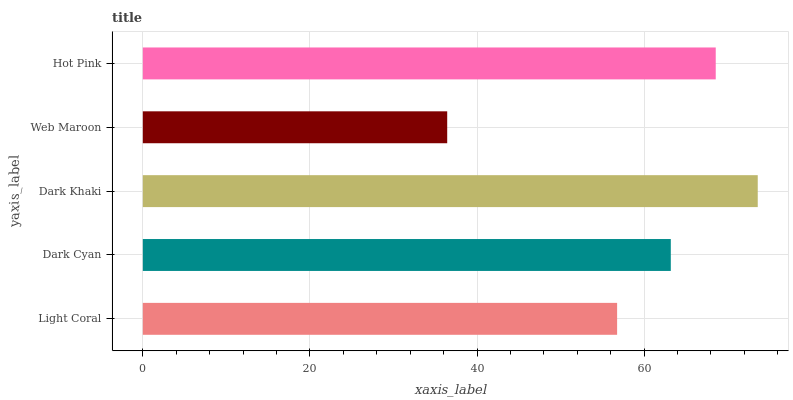Is Web Maroon the minimum?
Answer yes or no. Yes. Is Dark Khaki the maximum?
Answer yes or no. Yes. Is Dark Cyan the minimum?
Answer yes or no. No. Is Dark Cyan the maximum?
Answer yes or no. No. Is Dark Cyan greater than Light Coral?
Answer yes or no. Yes. Is Light Coral less than Dark Cyan?
Answer yes or no. Yes. Is Light Coral greater than Dark Cyan?
Answer yes or no. No. Is Dark Cyan less than Light Coral?
Answer yes or no. No. Is Dark Cyan the high median?
Answer yes or no. Yes. Is Dark Cyan the low median?
Answer yes or no. Yes. Is Web Maroon the high median?
Answer yes or no. No. Is Dark Khaki the low median?
Answer yes or no. No. 